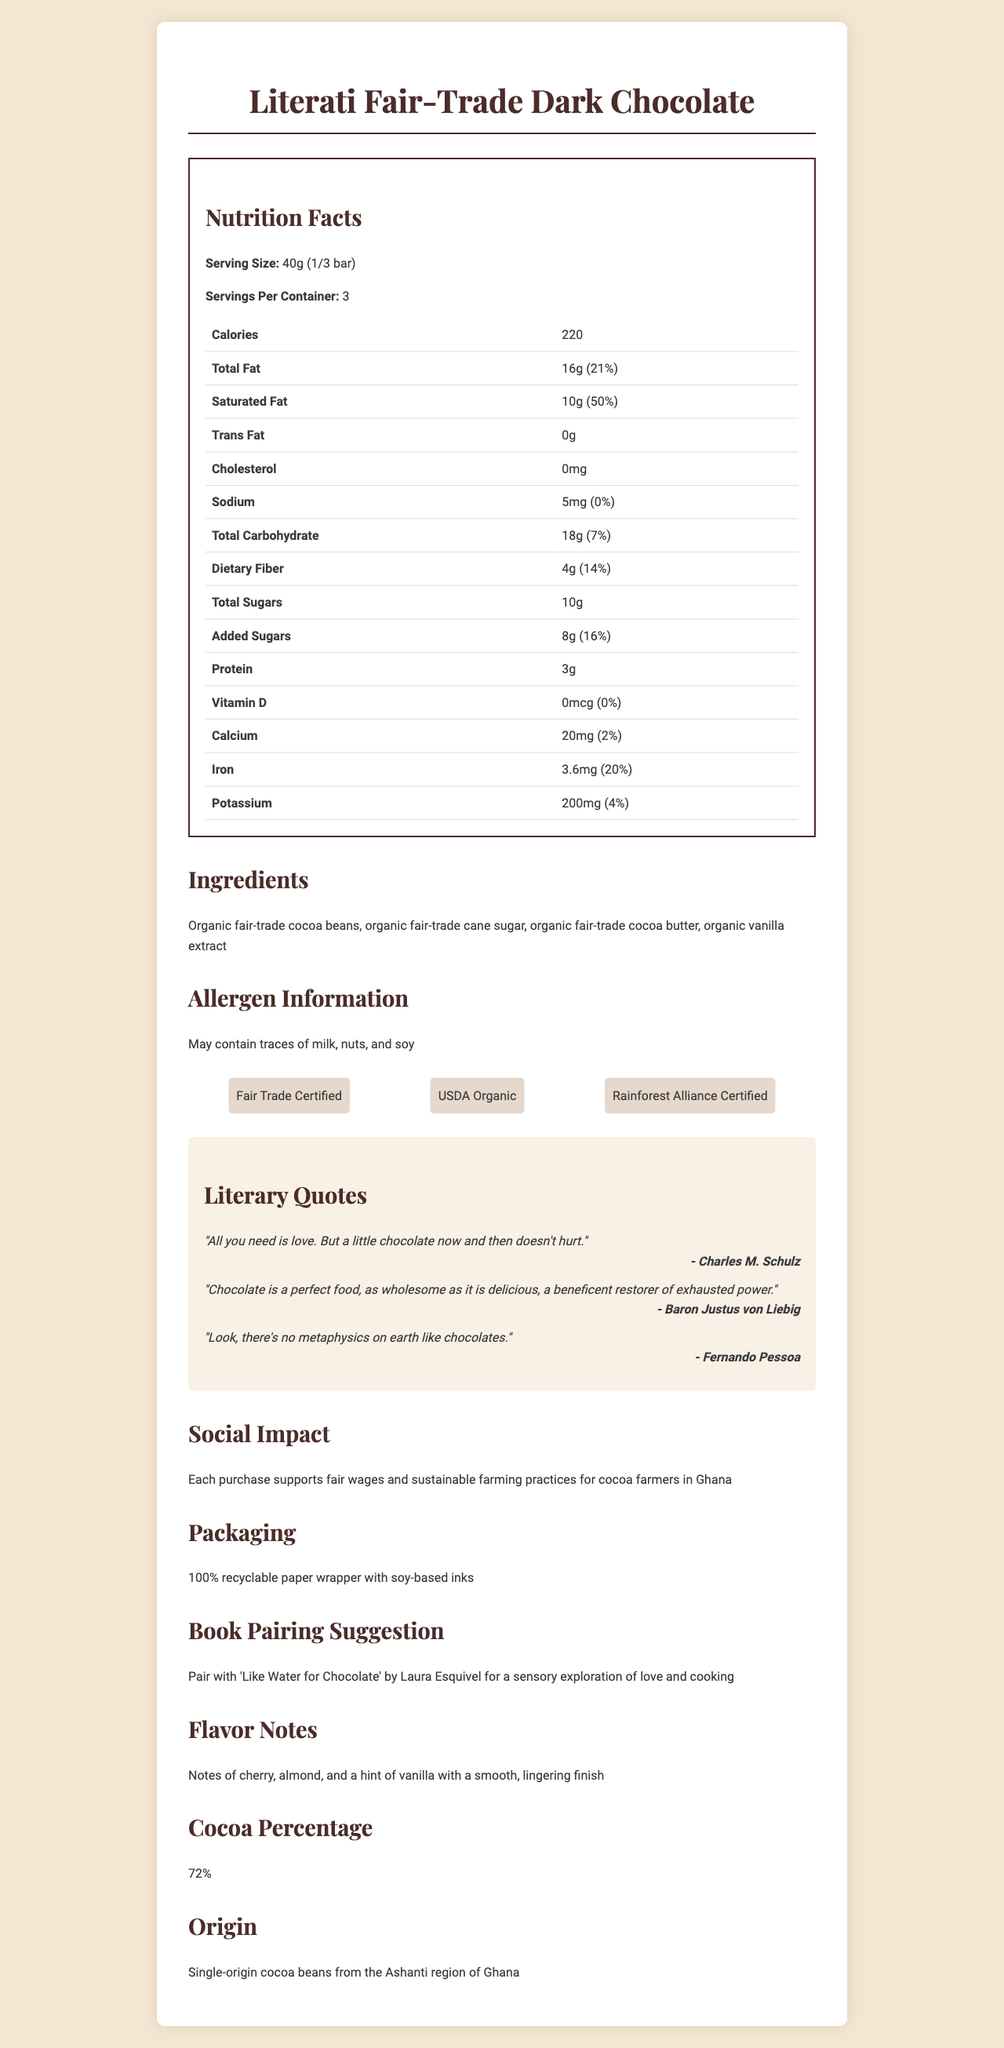what is the serving size of the chocolate bar? The serving size is listed as 40g (1/3 bar) in the document.
Answer: 40g (1/3 bar) how many servings are there per container? The document specifies that there are 3 servings per container.
Answer: 3 what certification labels are mentioned for the chocolate bar? The document lists these three certifications under the "certifications" section.
Answer: Fair Trade Certified, USDA Organic, Rainforest Alliance Certified how much total fat is in one serving of the chocolate bar? The total fat amount is listed as 16g in the nutrition facts section.
Answer: 16g what is the daily value percentage for saturated fat? The daily value percentage for saturated fat is 50%, as stated in the nutrition facts section.
Answer: 50% who is the author of the quote "All you need is love. But a little chocolate now and then doesn't hurt."? This quote is mentioned under the "literary quotes" section with Charles M. Schulz as the author.
Answer: Charles M. Schulz what flavors are noted in the chocolate bar? The flavor notes are described in the "Flavor Notes" section.
Answer: Notes of cherry, almond, and a hint of vanilla with a smooth, lingering finish what is the cocoa percentage of the chocolate bar? The cocoa percentage is listed as 72% in the "Cocoa Percentage" section.
Answer: 72% how much added sugar is there in one serving of the chocolate bar? The added sugars amount is 8g according to the nutrition facts section.
Answer: 8g which book is suggested to pair with this chocolate bar? The suggested book pairing is mentioned under the "Book Pairing Suggestion" section.
Answer: "Like Water for Chocolate" by Laura Esquivel what social impact does purchasing this chocolate bar support? The social impact is described in the "Social Impact" section.
Answer: fair wages and sustainable farming practices for cocoa farmers in Ghana how many calories are in one serving of the chocolate bar? The calorie content per serving is 220 calories, as stated in the nutrition facts section.
Answer: 220 where do the cocoa beans for this chocolate bar originate from? The origin is mentioned as the Ashanti region of Ghana in the document.
Answer: Ashanti region of Ghana which of the following certifications is NOT listed for the chocolate bar?
A. Fair Trade Certified
B. USDA Organic
C. Non-GMO Project Verified The listed certifications are Fair Trade Certified, USDA Organic, and Rainforest Alliance Certified, but not Non-GMO Project Verified.
Answer: C. Non-GMO Project Verified what is the daily value percentage for dietary fiber? The daily value percentage for dietary fiber is 14%, as mentioned in the nutrition facts section.
Answer: 14% does the chocolate bar contain any trans fats? The document specifies that there are 0g of trans fats in the chocolate bar.
Answer: No what is the total carbohydrate content per serving? The nutrition facts section lists the total carbohydrate content as 18g per serving.
Answer: 18g which quote is associated with the author Baron Justus von Liebig?
A. "All you need is love. But a little chocolate now and then doesn't hurt."
B. "Chocolate is a perfect food, as wholesome as it is delicious, a beneficent restorer of exhausted power."
C. "Look, there's no metaphysics on earth like chocolates." This quote is attributed to Baron Justus von Liebig in the "Literary Quotes" section.
Answer: B. "Chocolate is a perfect food, as wholesome as it is delicious, a beneficent restorer of exhausted power." does the document provide any information about the chocolate bar's country of production? The document only specifies the origin of the cocoa beans but does not explicitly state the country of production for the chocolate bar.
Answer: Not enough information summarize the main features of the Literati Fair-Trade Dark Chocolate document. The document is structured to inform about the nutritional content, the ethical and sustainable sourcing of ingredients, and the overall consumer experience, including flavor and pairing suggestions. The use of literary quotes adds a unique touch to the product’s presentation.
Answer: The Literati Fair-Trade Dark Chocolate document provides detailed information about the product, including nutrition facts, ingredients, certifications, allergen info, literary quotes, social impact, packaging, flavor notes, book pairing suggestion, cocoa percentage, and origin. It emphasizes the ethical sourcing, sustainable practices, and quality of the product, and it integrates literary quotes to highlight its cultural appeal. 